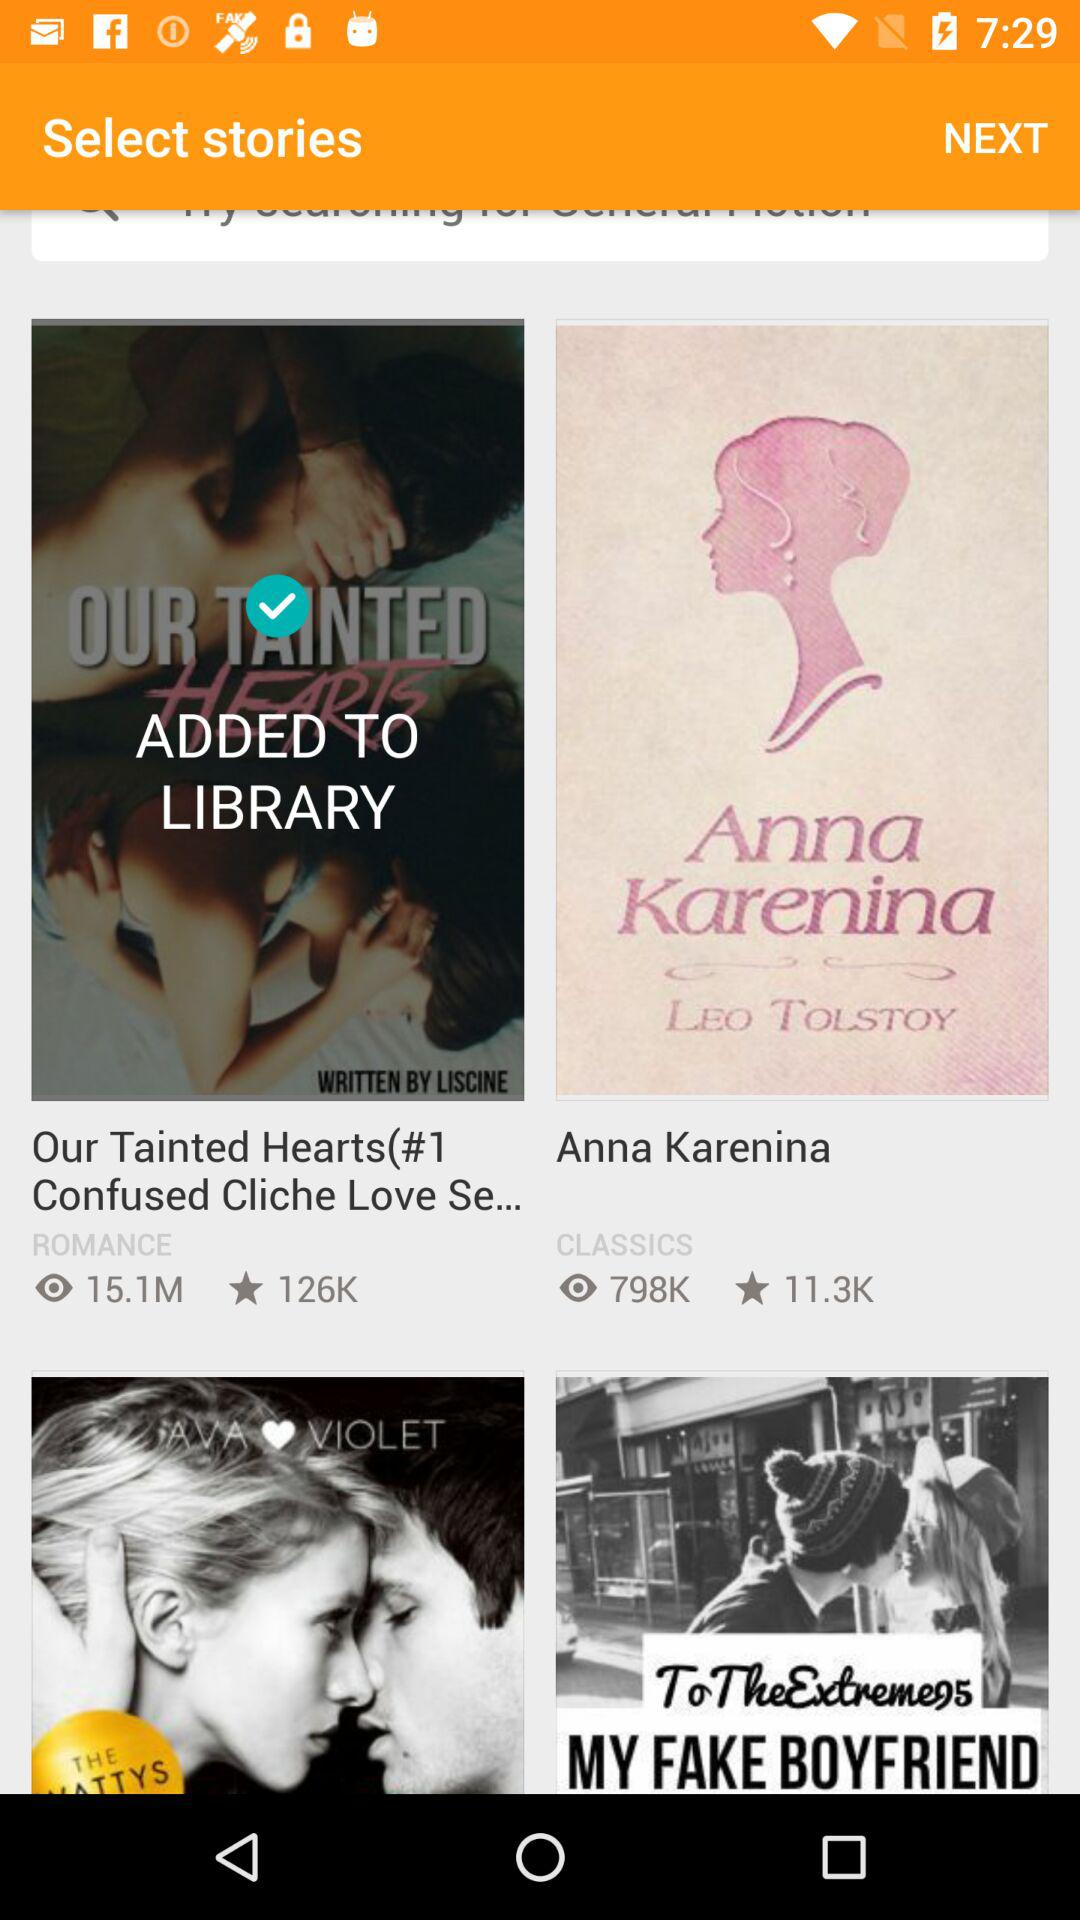How many stars are given to "Our Tainted Hearts(#1 Confused Cliche Love Se..."? There are 126000 stars given to "Our Tainted Hearts(#1 Confused Cliche Love Se...". 